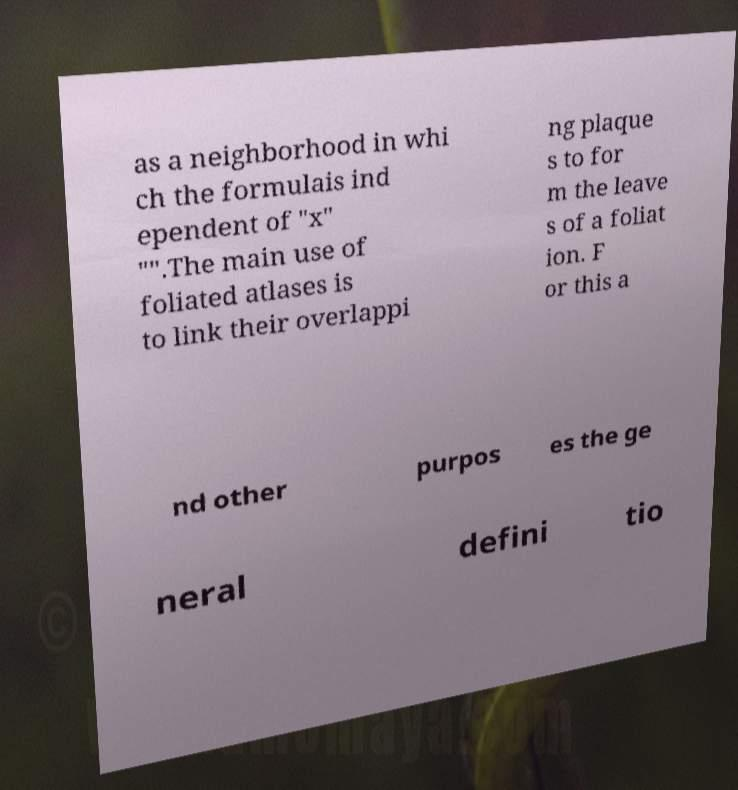Can you accurately transcribe the text from the provided image for me? as a neighborhood in whi ch the formulais ind ependent of "x" "".The main use of foliated atlases is to link their overlappi ng plaque s to for m the leave s of a foliat ion. F or this a nd other purpos es the ge neral defini tio 